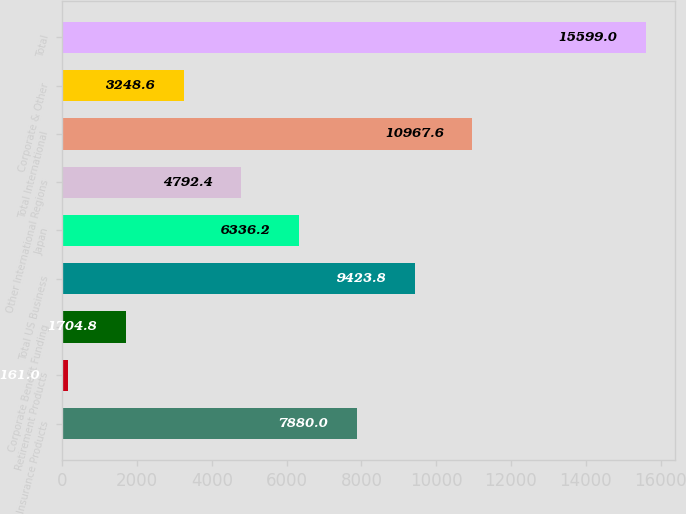<chart> <loc_0><loc_0><loc_500><loc_500><bar_chart><fcel>Insurance Products<fcel>Retirement Products<fcel>Corporate Benefit Funding<fcel>Total US Business<fcel>Japan<fcel>Other International Regions<fcel>Total International<fcel>Corporate & Other<fcel>Total<nl><fcel>7880<fcel>161<fcel>1704.8<fcel>9423.8<fcel>6336.2<fcel>4792.4<fcel>10967.6<fcel>3248.6<fcel>15599<nl></chart> 